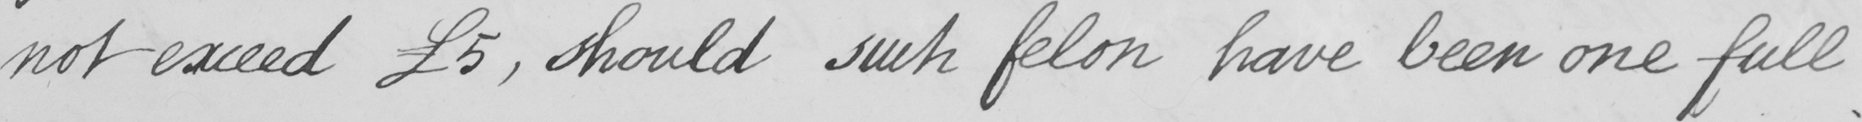Can you tell me what this handwritten text says? not exceed  £5 , should such felon have been one full 